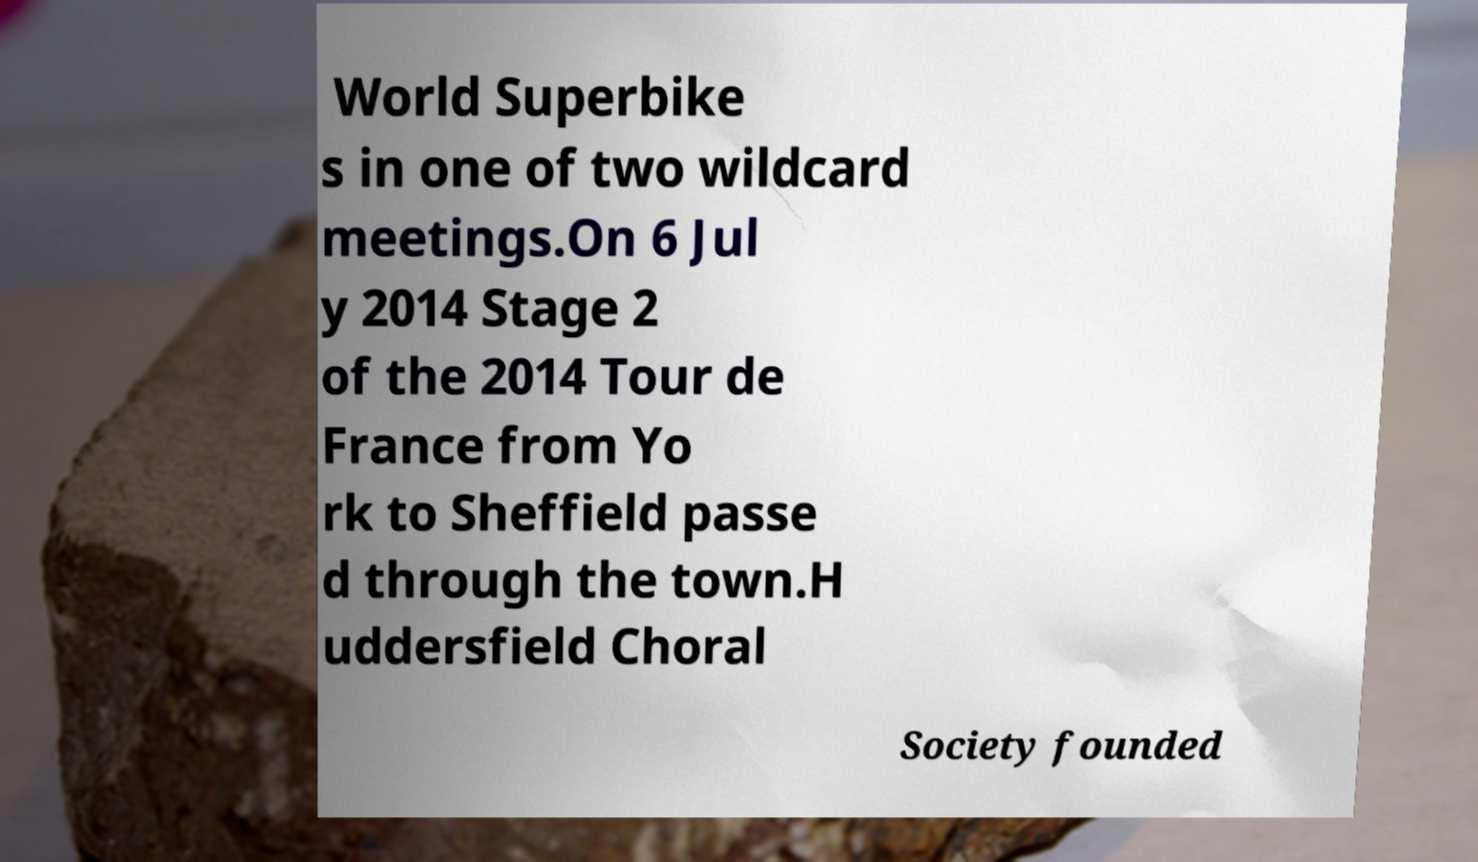There's text embedded in this image that I need extracted. Can you transcribe it verbatim? World Superbike s in one of two wildcard meetings.On 6 Jul y 2014 Stage 2 of the 2014 Tour de France from Yo rk to Sheffield passe d through the town.H uddersfield Choral Society founded 